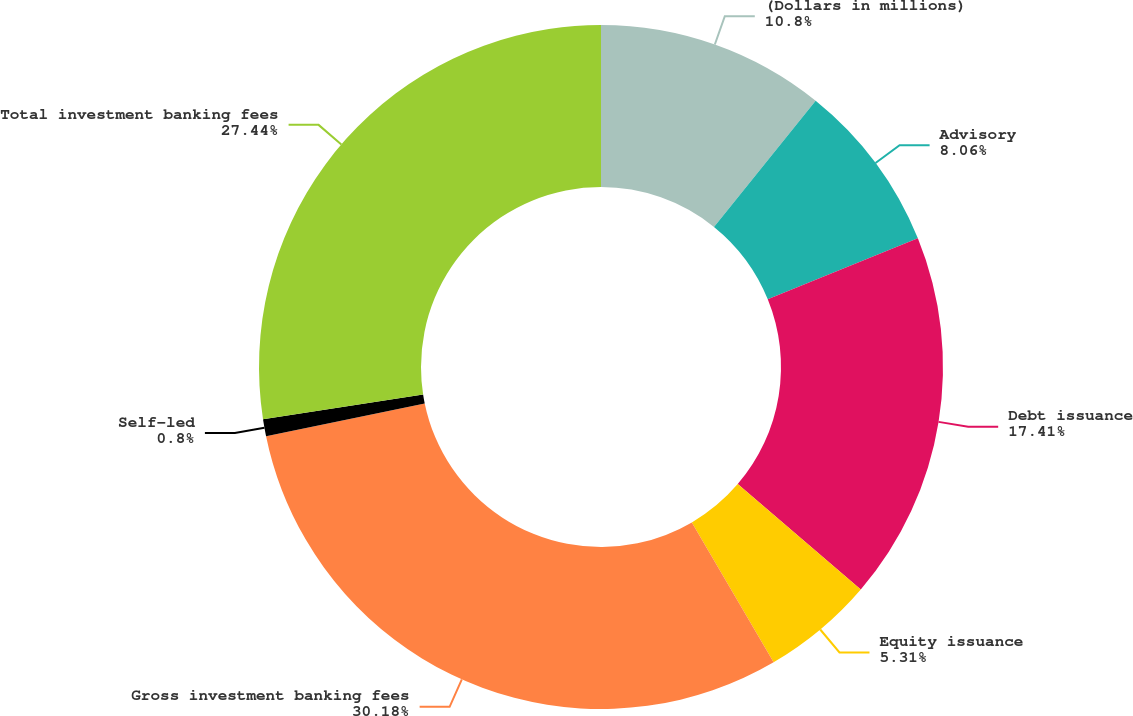Convert chart. <chart><loc_0><loc_0><loc_500><loc_500><pie_chart><fcel>(Dollars in millions)<fcel>Advisory<fcel>Debt issuance<fcel>Equity issuance<fcel>Gross investment banking fees<fcel>Self-led<fcel>Total investment banking fees<nl><fcel>10.8%<fcel>8.06%<fcel>17.41%<fcel>5.31%<fcel>30.18%<fcel>0.8%<fcel>27.44%<nl></chart> 